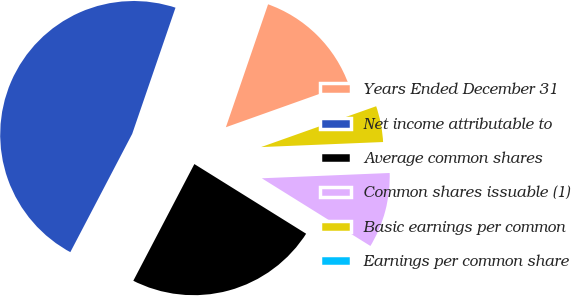<chart> <loc_0><loc_0><loc_500><loc_500><pie_chart><fcel>Years Ended December 31<fcel>Net income attributable to<fcel>Average common shares<fcel>Common shares issuable (1)<fcel>Basic earnings per common<fcel>Earnings per common share<nl><fcel>14.29%<fcel>47.59%<fcel>23.8%<fcel>9.53%<fcel>4.77%<fcel>0.02%<nl></chart> 